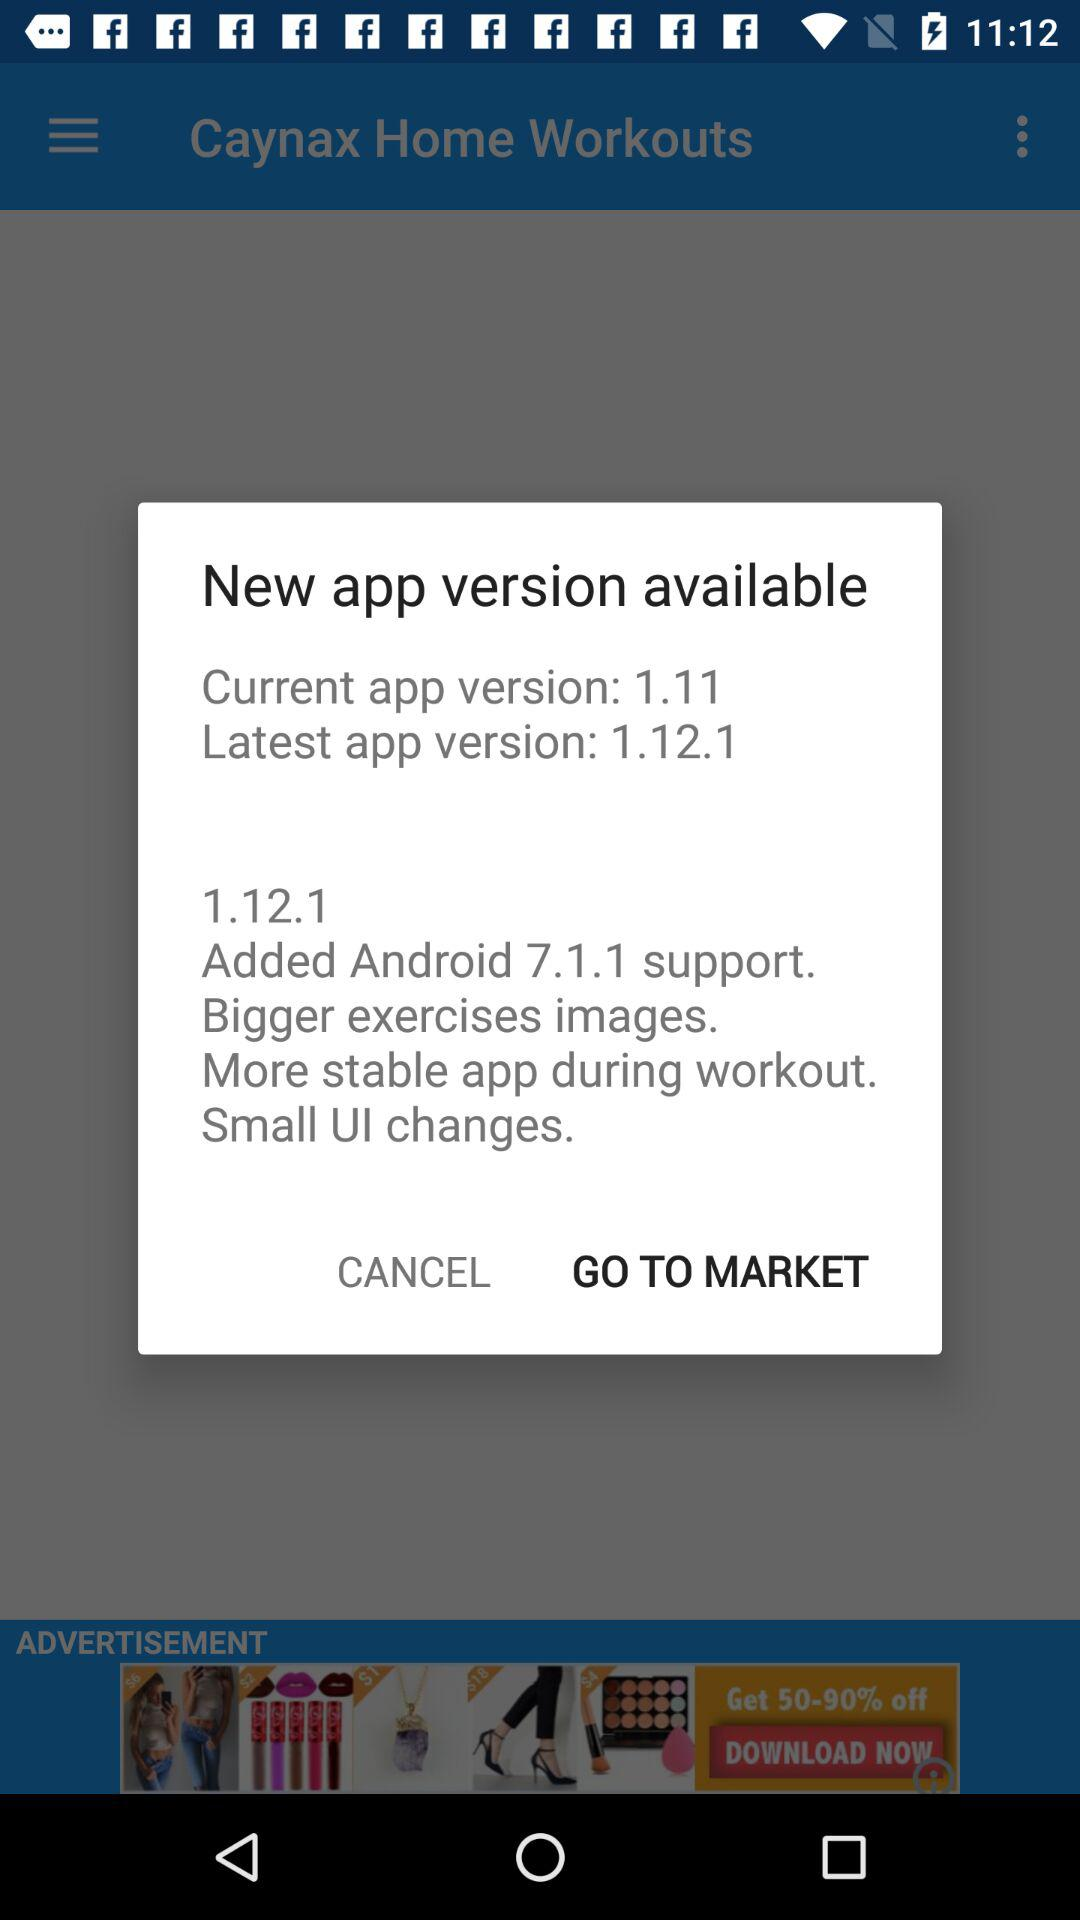What are the updates in version 1.12.1? The updates in version 1.12.1 are "Added Android 7.1.1 support", "Bigger exercises images", "More stable app during workout" and "Small UI changes". 